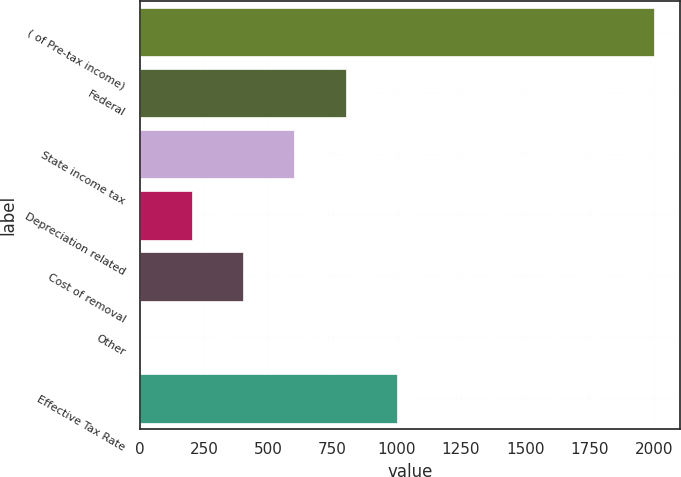Convert chart. <chart><loc_0><loc_0><loc_500><loc_500><bar_chart><fcel>( of Pre-tax income)<fcel>Federal<fcel>State income tax<fcel>Depreciation related<fcel>Cost of removal<fcel>Other<fcel>Effective Tax Rate<nl><fcel>2003<fcel>801.8<fcel>601.6<fcel>201.2<fcel>401.4<fcel>1<fcel>1002<nl></chart> 